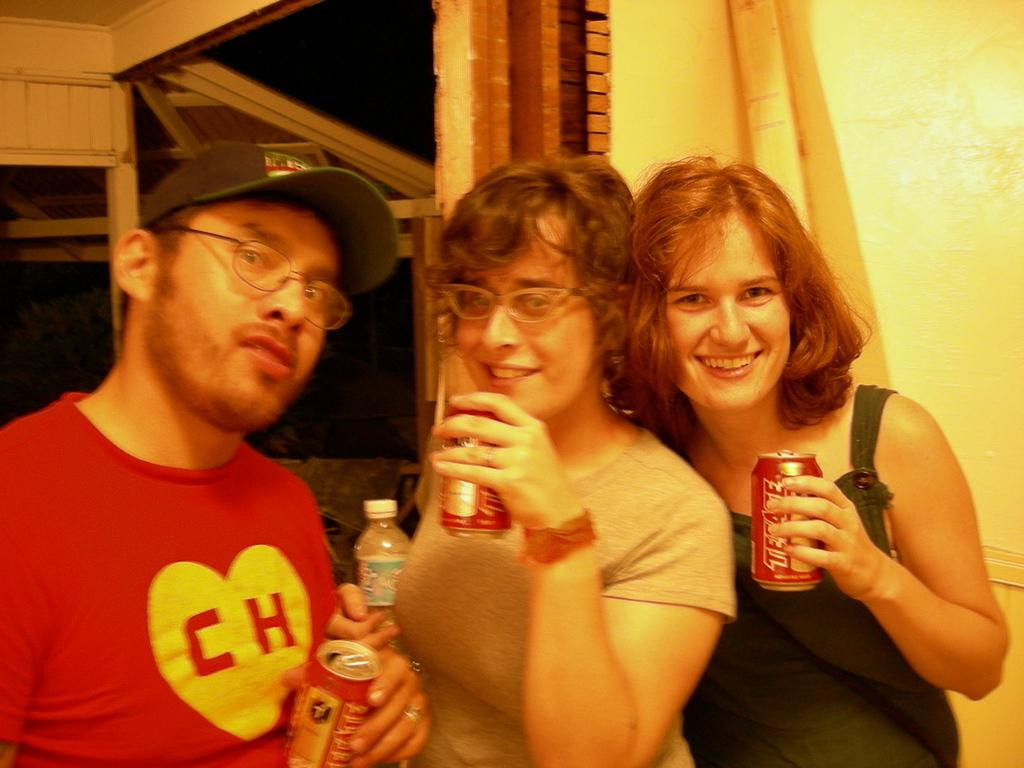How many people are in the foreground of the image? There are three persons in the foreground of the image. What are the people doing in the image? The persons are standing in the image. What objects are the people holding in the image? The persons are holding coke containers and a bottle in the image. What can be seen in the background of the image? There is a wall and wooden boards in the background of the image. What type of disease can be seen spreading among the people in the image? There is no indication of any disease in the image; the people are simply standing and holding coke containers and a bottle. What type of books are visible on the wooden boards in the background? There are no books visible on the wooden boards in the background; only the wall and wooden boards can be seen. 